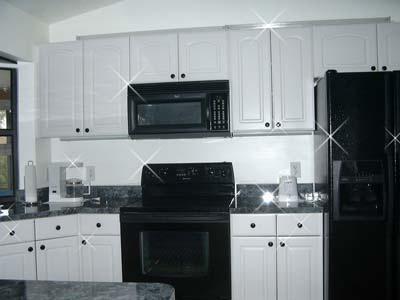How many giraffes are there standing in the sun?
Give a very brief answer. 0. 